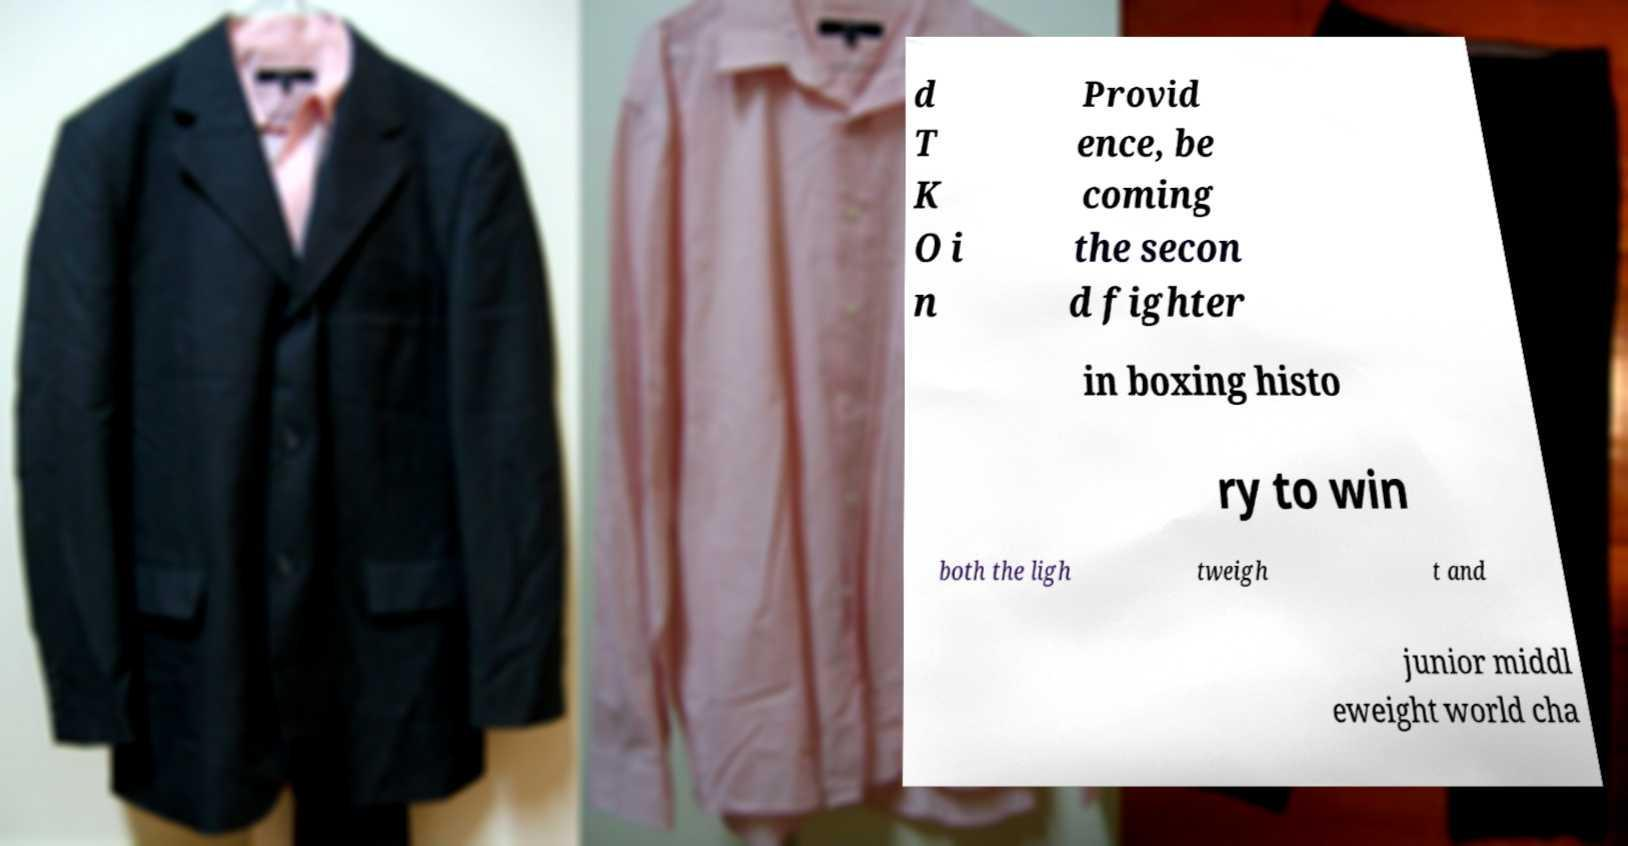Can you accurately transcribe the text from the provided image for me? d T K O i n Provid ence, be coming the secon d fighter in boxing histo ry to win both the ligh tweigh t and junior middl eweight world cha 